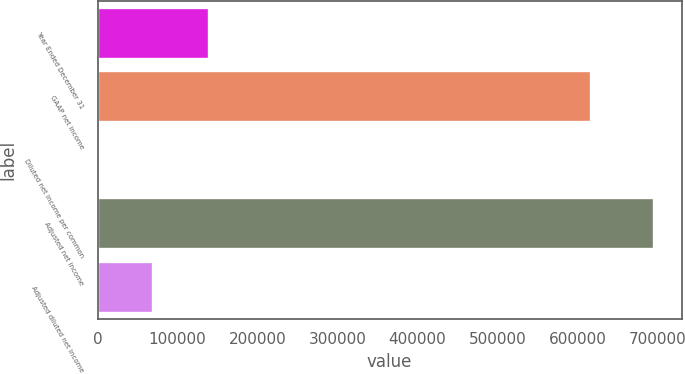Convert chart. <chart><loc_0><loc_0><loc_500><loc_500><bar_chart><fcel>Year Ended December 31<fcel>GAAP net income<fcel>Diluted net income per common<fcel>Adjusted net income<fcel>Adjusted diluted net income<nl><fcel>139160<fcel>616757<fcel>4.18<fcel>695782<fcel>69582<nl></chart> 